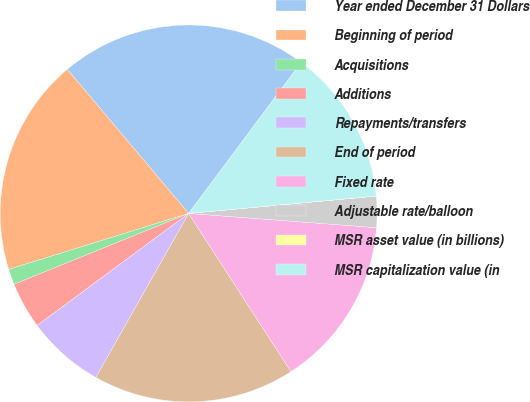Convert chart to OTSL. <chart><loc_0><loc_0><loc_500><loc_500><pie_chart><fcel>Year ended December 31 Dollars<fcel>Beginning of period<fcel>Acquisitions<fcel>Additions<fcel>Repayments/transfers<fcel>End of period<fcel>Fixed rate<fcel>Adjustable rate/balloon<fcel>MSR asset value (in billions)<fcel>MSR capitalization value (in<nl><fcel>21.33%<fcel>18.66%<fcel>1.34%<fcel>4.0%<fcel>6.67%<fcel>17.33%<fcel>14.66%<fcel>2.67%<fcel>0.01%<fcel>13.33%<nl></chart> 